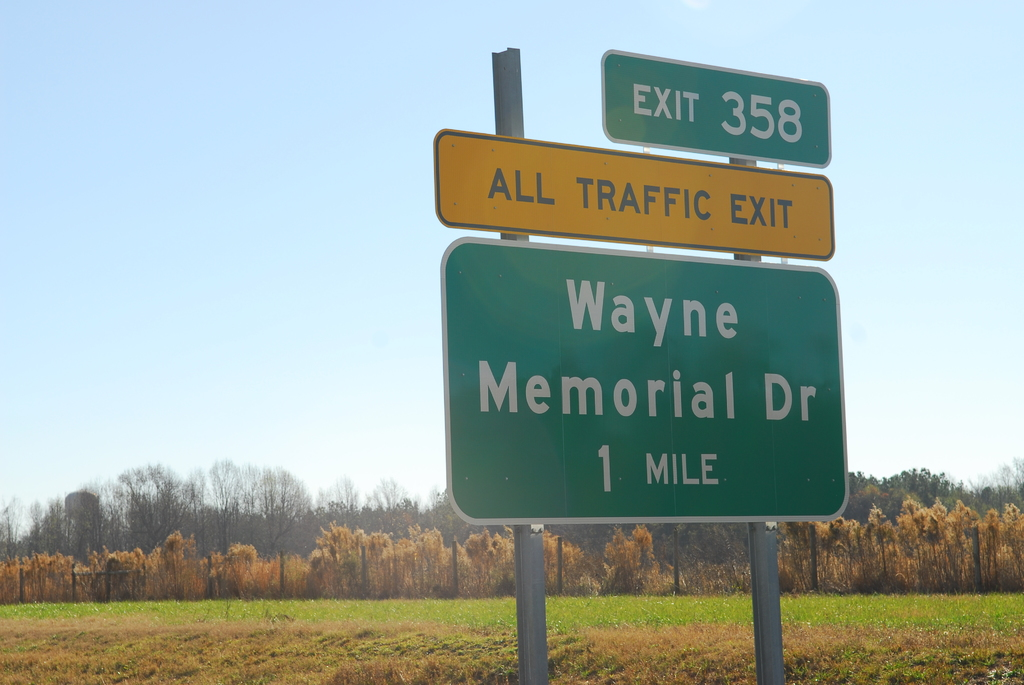What do you see happening in this image? The image captures a moment on a highway, where a green exit sign stands prominently on the side of the road. The sign indicates that Exit 358 for Wayne Memorial Drive is one mile ahead. It's noteworthy that the sign specifies "ALL TRAFFIC EXIT", suggesting that all vehicles must take this exit. The setting is a typical day on the highway, with a clear blue sky overhead and a field with trees in the distance. The sign, with its bold white text against a green background, serves as a crucial guide for drivers navigating this stretch of the road. 